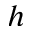Convert formula to latex. <formula><loc_0><loc_0><loc_500><loc_500>h</formula> 